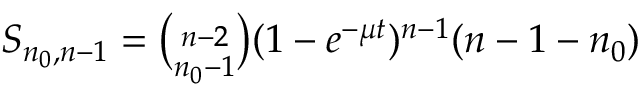Convert formula to latex. <formula><loc_0><loc_0><loc_500><loc_500>\begin{array} { r } { S _ { n _ { 0 } , n - 1 } = { \binom { n - 2 } { n _ { 0 } - 1 } } ( 1 - e ^ { - \mu t } ) ^ { n - 1 } ( n - 1 - n _ { 0 } ) } \end{array}</formula> 